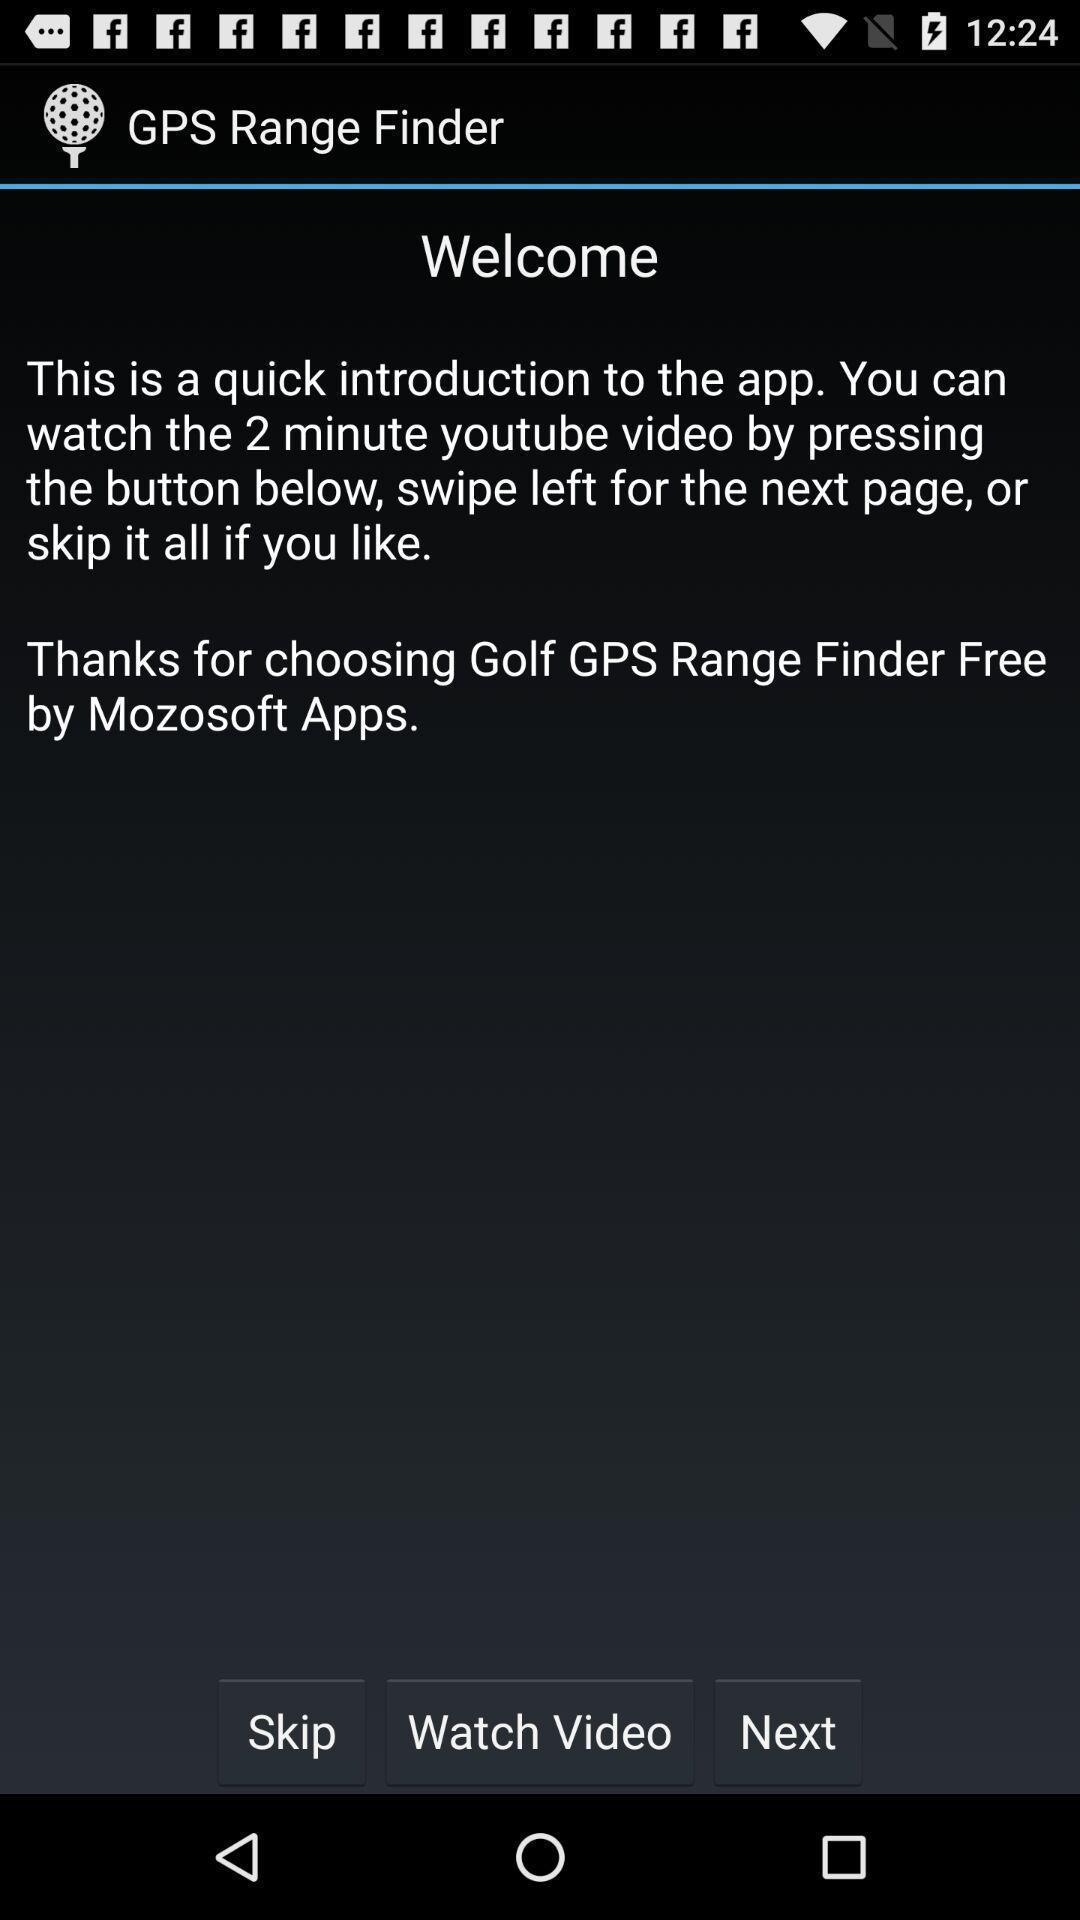Tell me what you see in this picture. Welcome page of social app. 